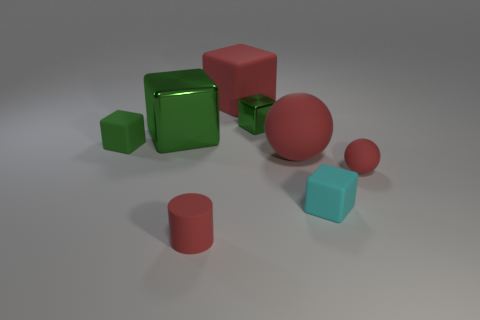What is the size of the metal block behind the big metal thing that is behind the cyan cube?
Give a very brief answer. Small. What is the color of the other big rubber thing that is the same shape as the green matte thing?
Offer a terse response. Red. What is the size of the red cube?
Keep it short and to the point. Large. How many cubes are large purple shiny things or big things?
Give a very brief answer. 2. There is a red matte object that is the same shape as the cyan rubber object; what is its size?
Your answer should be compact. Large. What number of small green rubber things are there?
Ensure brevity in your answer.  1. Is the shape of the small metallic object the same as the small red object that is on the right side of the tiny metal block?
Ensure brevity in your answer.  No. What size is the cylinder that is left of the red rubber cube?
Your answer should be very brief. Small. What is the material of the cylinder?
Your answer should be compact. Rubber. There is a red rubber object behind the green matte cube; is it the same shape as the cyan thing?
Give a very brief answer. Yes. 